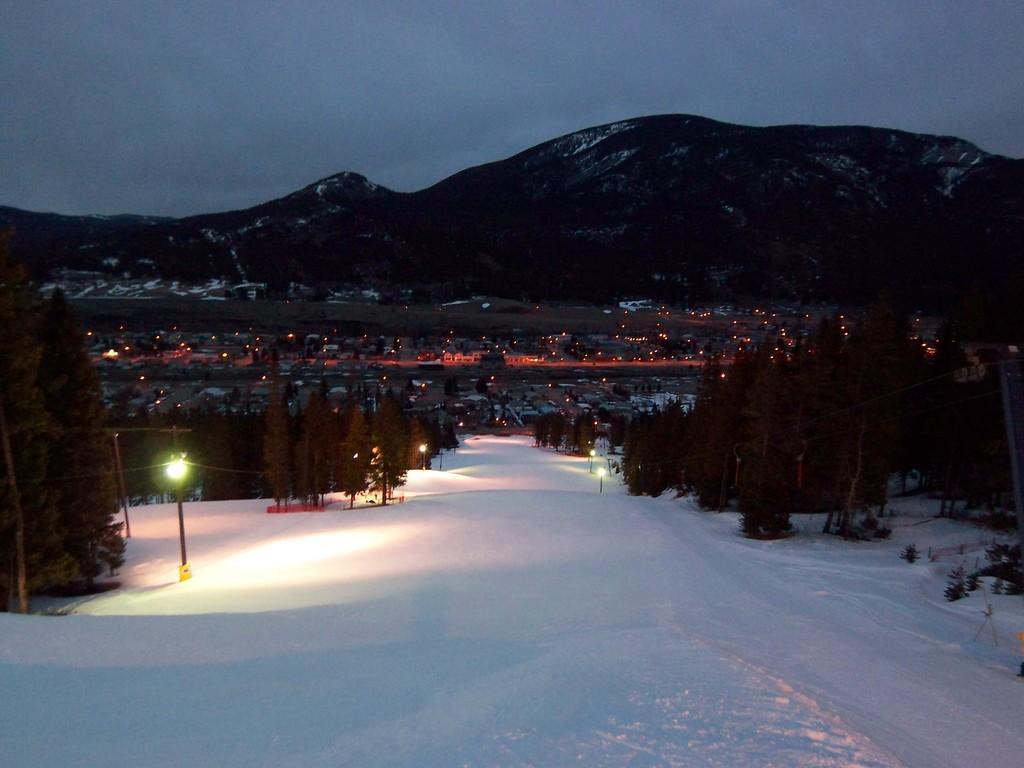How would you summarize this image in a sentence or two? At the down side this is snow, on the left side there are trees and lights. At the back side there are hills. 